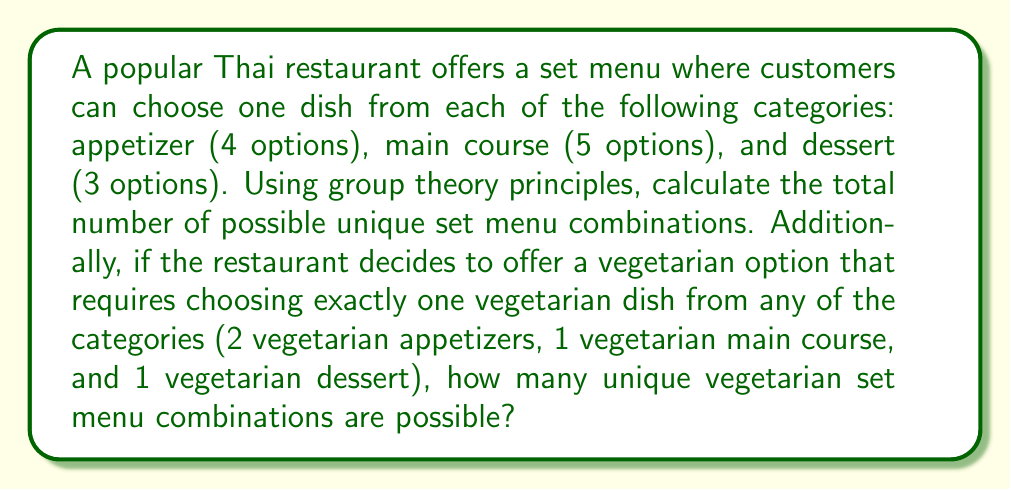Can you answer this question? Let's approach this problem using the fundamental principles of group theory:

1. Total number of combinations:
   We can consider each category as a set, and the Cartesian product of these sets will give us the total number of combinations.
   
   Let $A$ be the set of appetizers, $M$ be the set of main courses, and $D$ be the set of desserts.
   
   $|A| = 4$, $|M| = 5$, $|D| = 3$
   
   Total combinations = $|A \times M \times D| = |A| \cdot |M| \cdot |D| = 4 \cdot 5 \cdot 3 = 60$

2. Vegetarian combinations:
   For the vegetarian option, we need to use the inclusion-exclusion principle from group theory.
   
   Let $V_A$, $V_M$, and $V_D$ be the events of choosing a vegetarian dish from appetizers, main courses, and desserts respectively.
   
   $|V_A| = 2$, $|V_M| = 1$, $|V_D| = 1$
   
   We want exactly one vegetarian dish, so we calculate:
   
   $|V_A \cup V_M \cup V_D| = |V_A| + |V_M| + |V_D| - |V_A \cap V_M| - |V_A \cap V_D| - |V_M \cap V_D| + |V_A \cap V_M \cap V_D|$
   
   $= 2 + 1 + 1 - 0 - 0 - 0 + 0 = 4$

   Now, for each of these 4 ways to choose a vegetarian dish, we need to multiply by the number of ways to choose non-vegetarian dishes from the other two categories:
   
   - If vegetarian appetizer: $2 \cdot 4 \cdot 3 = 24$
   - If vegetarian main course: $4 \cdot 1 \cdot 3 = 12$
   - If vegetarian dessert: $4 \cdot 5 \cdot 1 = 20$
   
   Total vegetarian combinations = $24 + 12 + 20 = 56$
Answer: The total number of possible unique set menu combinations is $60$. The number of unique vegetarian set menu combinations is $56$. 